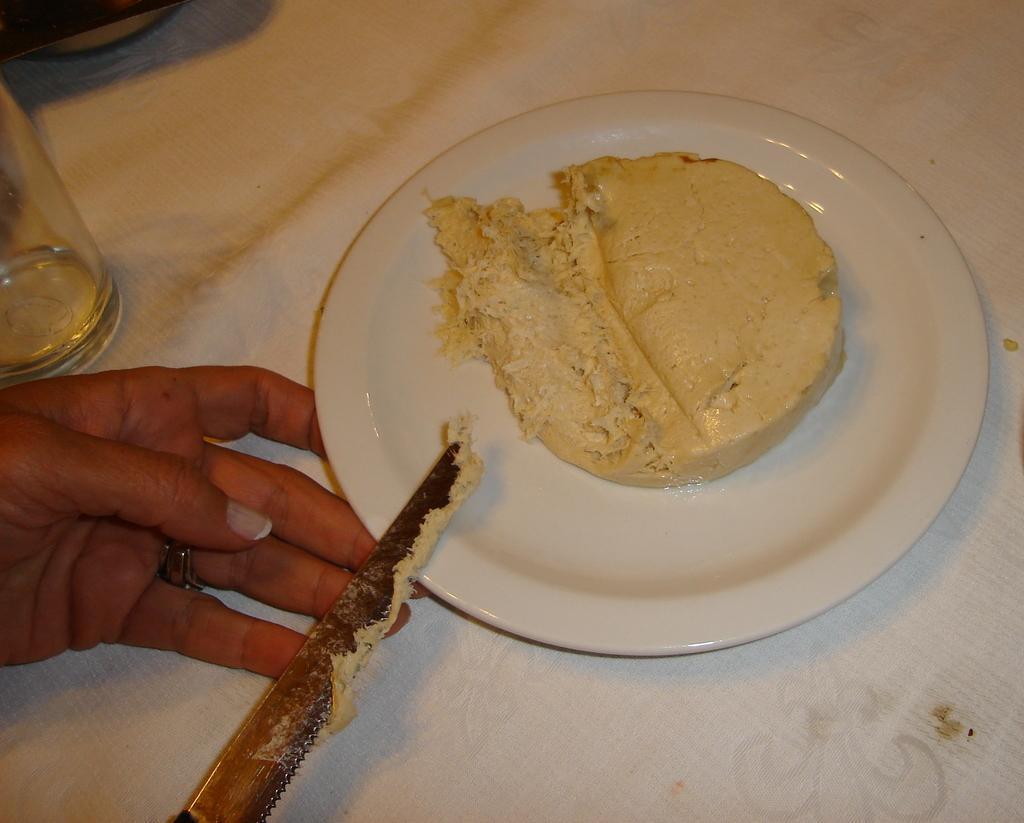Could you give a brief overview of what you see in this image? This image is taken indoors. At the bottom of the image there is a table with a table cloth, a glass and a plate with a food item on it. On the left side of the image a person is holding a knife. 